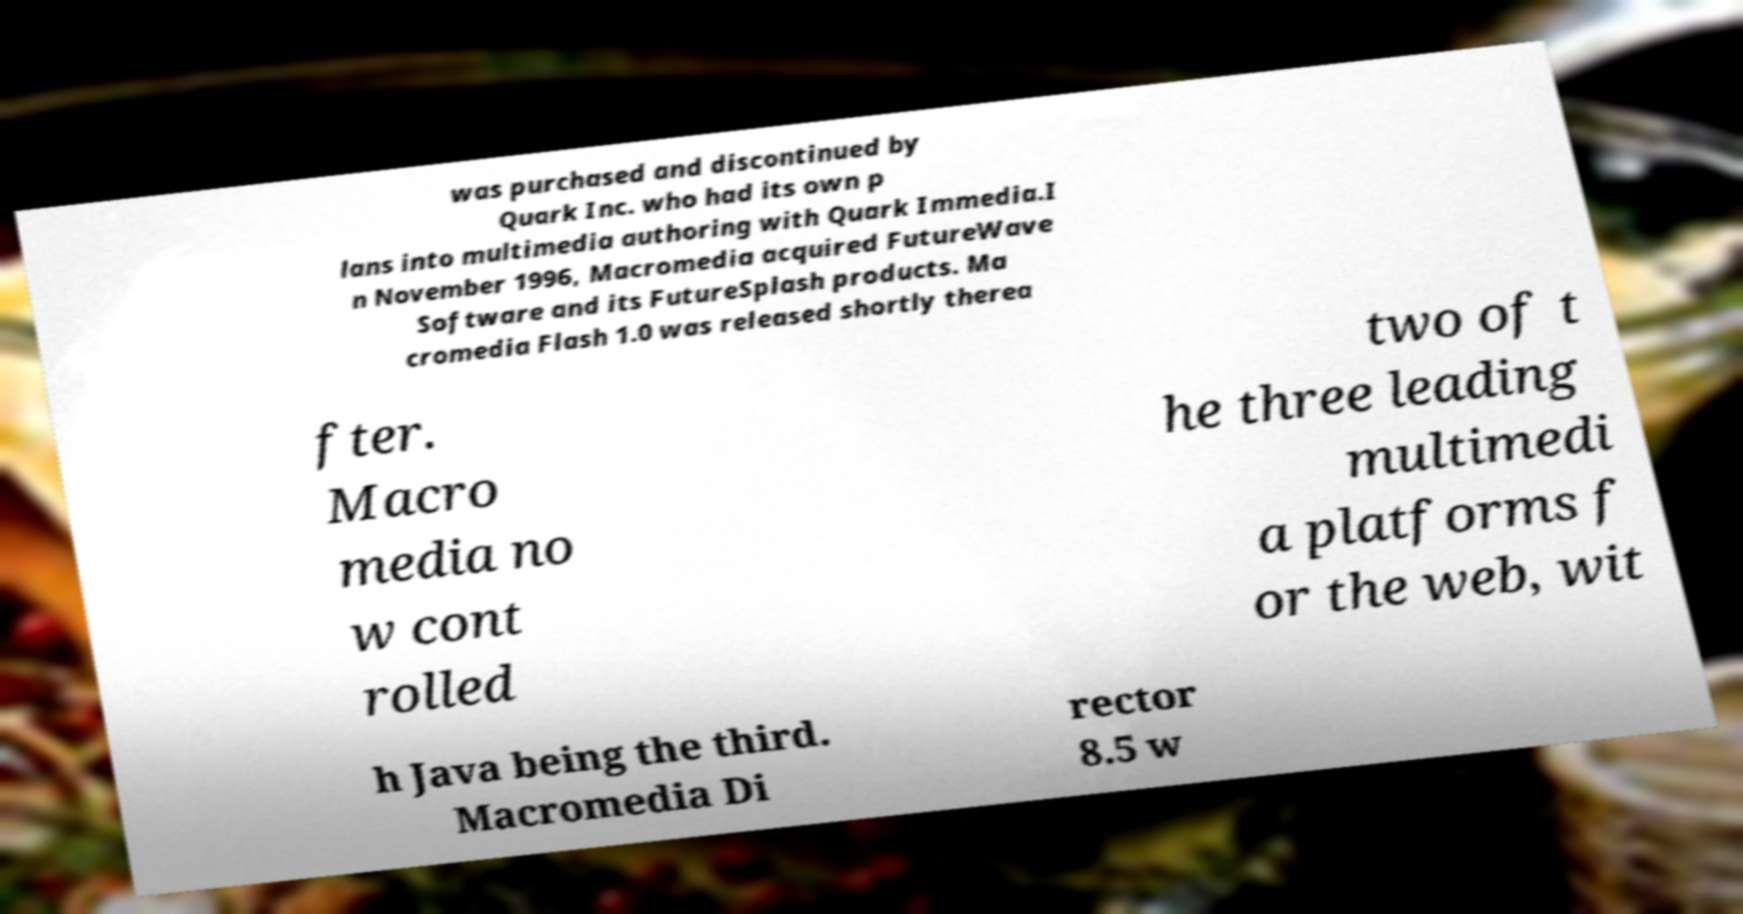Could you extract and type out the text from this image? was purchased and discontinued by Quark Inc. who had its own p lans into multimedia authoring with Quark Immedia.I n November 1996, Macromedia acquired FutureWave Software and its FutureSplash products. Ma cromedia Flash 1.0 was released shortly therea fter. Macro media no w cont rolled two of t he three leading multimedi a platforms f or the web, wit h Java being the third. Macromedia Di rector 8.5 w 